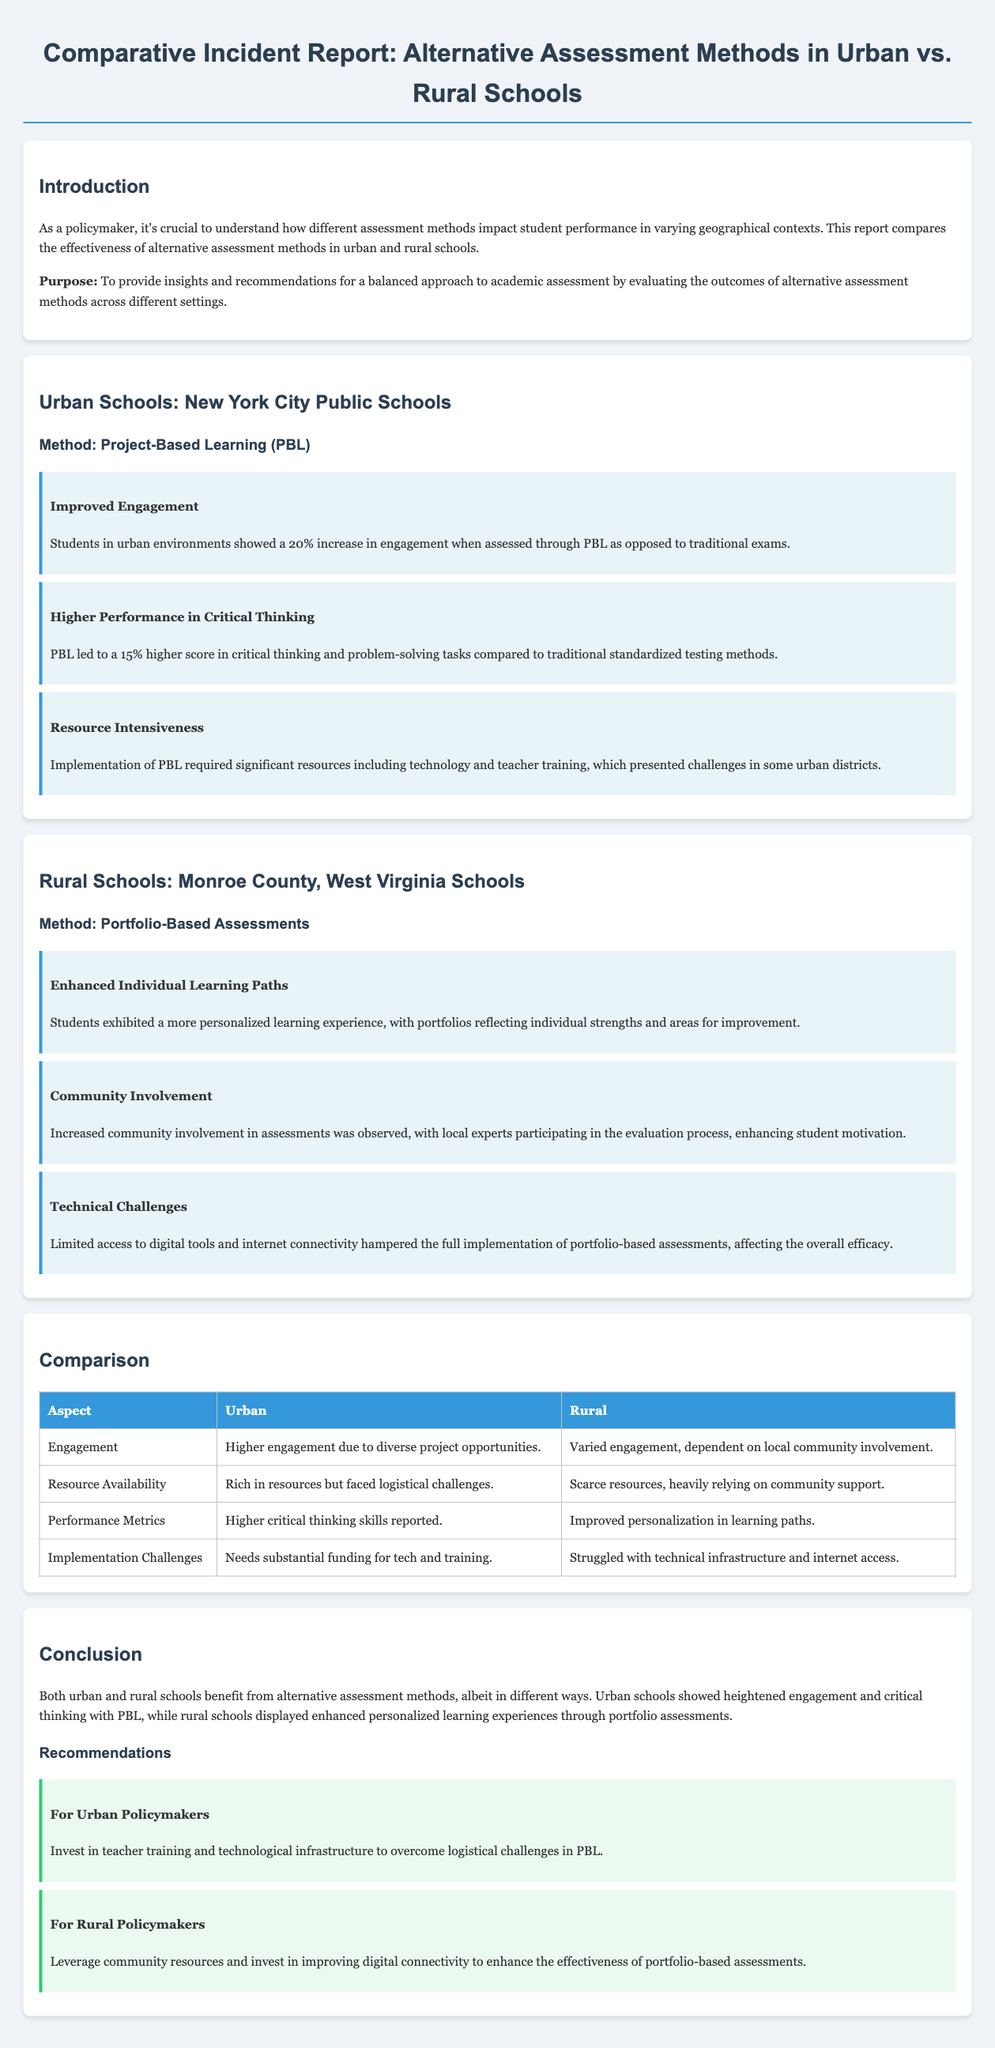what was the increase in engagement for urban students using project-based learning? The report states that students in urban environments showed a 20% increase in engagement when assessed through PBL.
Answer: 20% how much higher was the critical thinking score for urban students? The report indicates that PBL led to a 15% higher score in critical thinking and problem-solving tasks compared to traditional standardized testing methods.
Answer: 15% what assessment method was used in rural schools? The report mentions that rural schools utilized Portfolio-Based Assessments.
Answer: Portfolio-Based Assessments what enhanced the personalization of learning experiences in rural schools? The use of portfolios reflected individual strengths and areas for improvement, enhancing personalized learning experiences.
Answer: Portfolios how did community involvement affect assessments in rural schools? Increased community involvement in assessments was observed, enhancing student motivation as local experts participated in the evaluation process.
Answer: Enhanced student motivation what was one major challenge for implementing project-based learning in urban schools? The report highlights that PBL required significant resources, including technology and teacher training, which presented challenges in some urban districts.
Answer: Resource Intensiveness which alternative assessment method showed challenges due to limited access to digital tools in rural schools? Limited access to digital tools and internet connectivity hampered the full implementation of portfolio-based assessments.
Answer: Portfolio-based assessments what is one recommendation for urban policymakers? The report recommends investing in teacher training and technological infrastructure to overcome logistical challenges in PBL.
Answer: Invest in teacher training what aspect saw varied engagement in rural schools? The report states that engagement in rural schools was dependent on local community involvement.
Answer: Local community involvement 